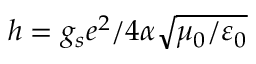Convert formula to latex. <formula><loc_0><loc_0><loc_500><loc_500>h = g _ { s } e ^ { 2 } / 4 \alpha \sqrt { \mu _ { 0 } / \varepsilon _ { 0 } }</formula> 